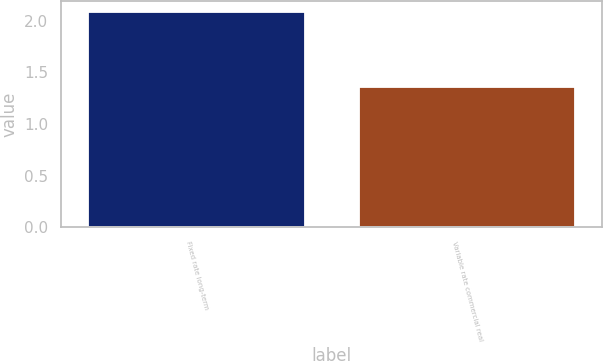Convert chart. <chart><loc_0><loc_0><loc_500><loc_500><bar_chart><fcel>Fixed rate long-term<fcel>Variable rate commercial real<nl><fcel>2.09<fcel>1.36<nl></chart> 